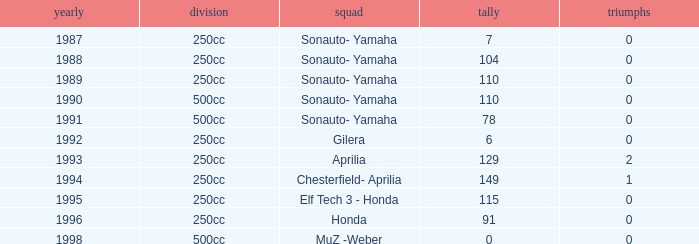What is the highest number of points the team with 0 wins had before 1992? 110.0. 